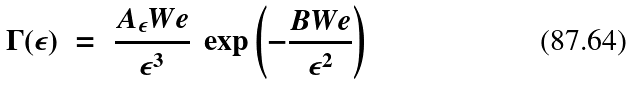<formula> <loc_0><loc_0><loc_500><loc_500>\Gamma ( \epsilon ) \ = \ \frac { A _ { \epsilon } W e } { \epsilon ^ { 3 } } \ \exp \left ( - \frac { B W e } { \epsilon ^ { 2 } } \right ) \</formula> 